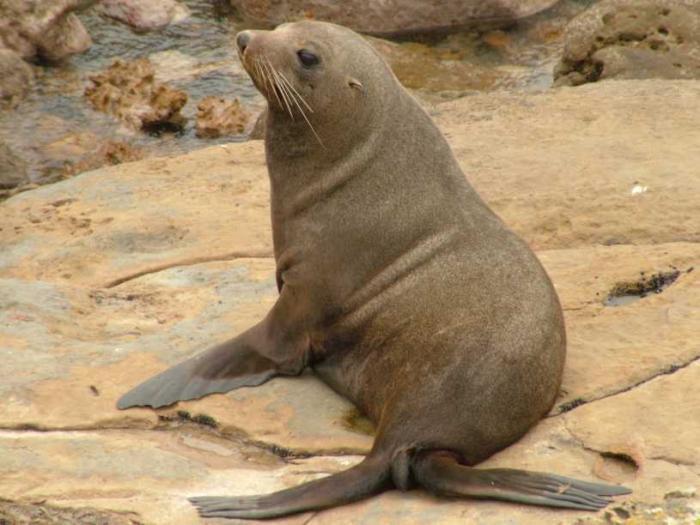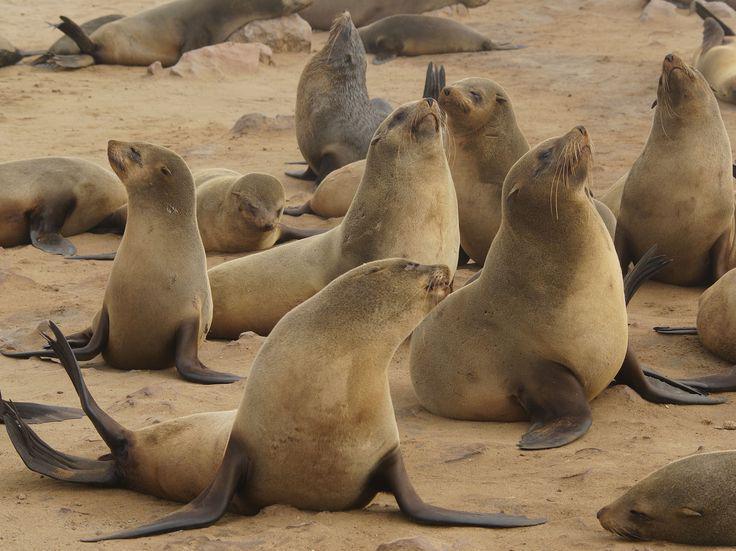The first image is the image on the left, the second image is the image on the right. Considering the images on both sides, is "There is water in the image on the left." valid? Answer yes or no. No. The first image is the image on the left, the second image is the image on the right. Considering the images on both sides, is "An image shows just one seal in the foreground, who is facing left." valid? Answer yes or no. Yes. The first image is the image on the left, the second image is the image on the right. Evaluate the accuracy of this statement regarding the images: "Right image shows one large mail seal and several small females.". Is it true? Answer yes or no. No. 